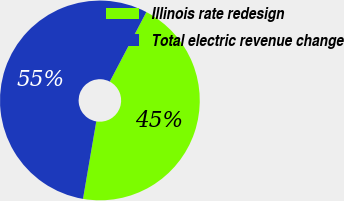<chart> <loc_0><loc_0><loc_500><loc_500><pie_chart><fcel>Illinois rate redesign<fcel>Total electric revenue change<nl><fcel>45.0%<fcel>55.0%<nl></chart> 